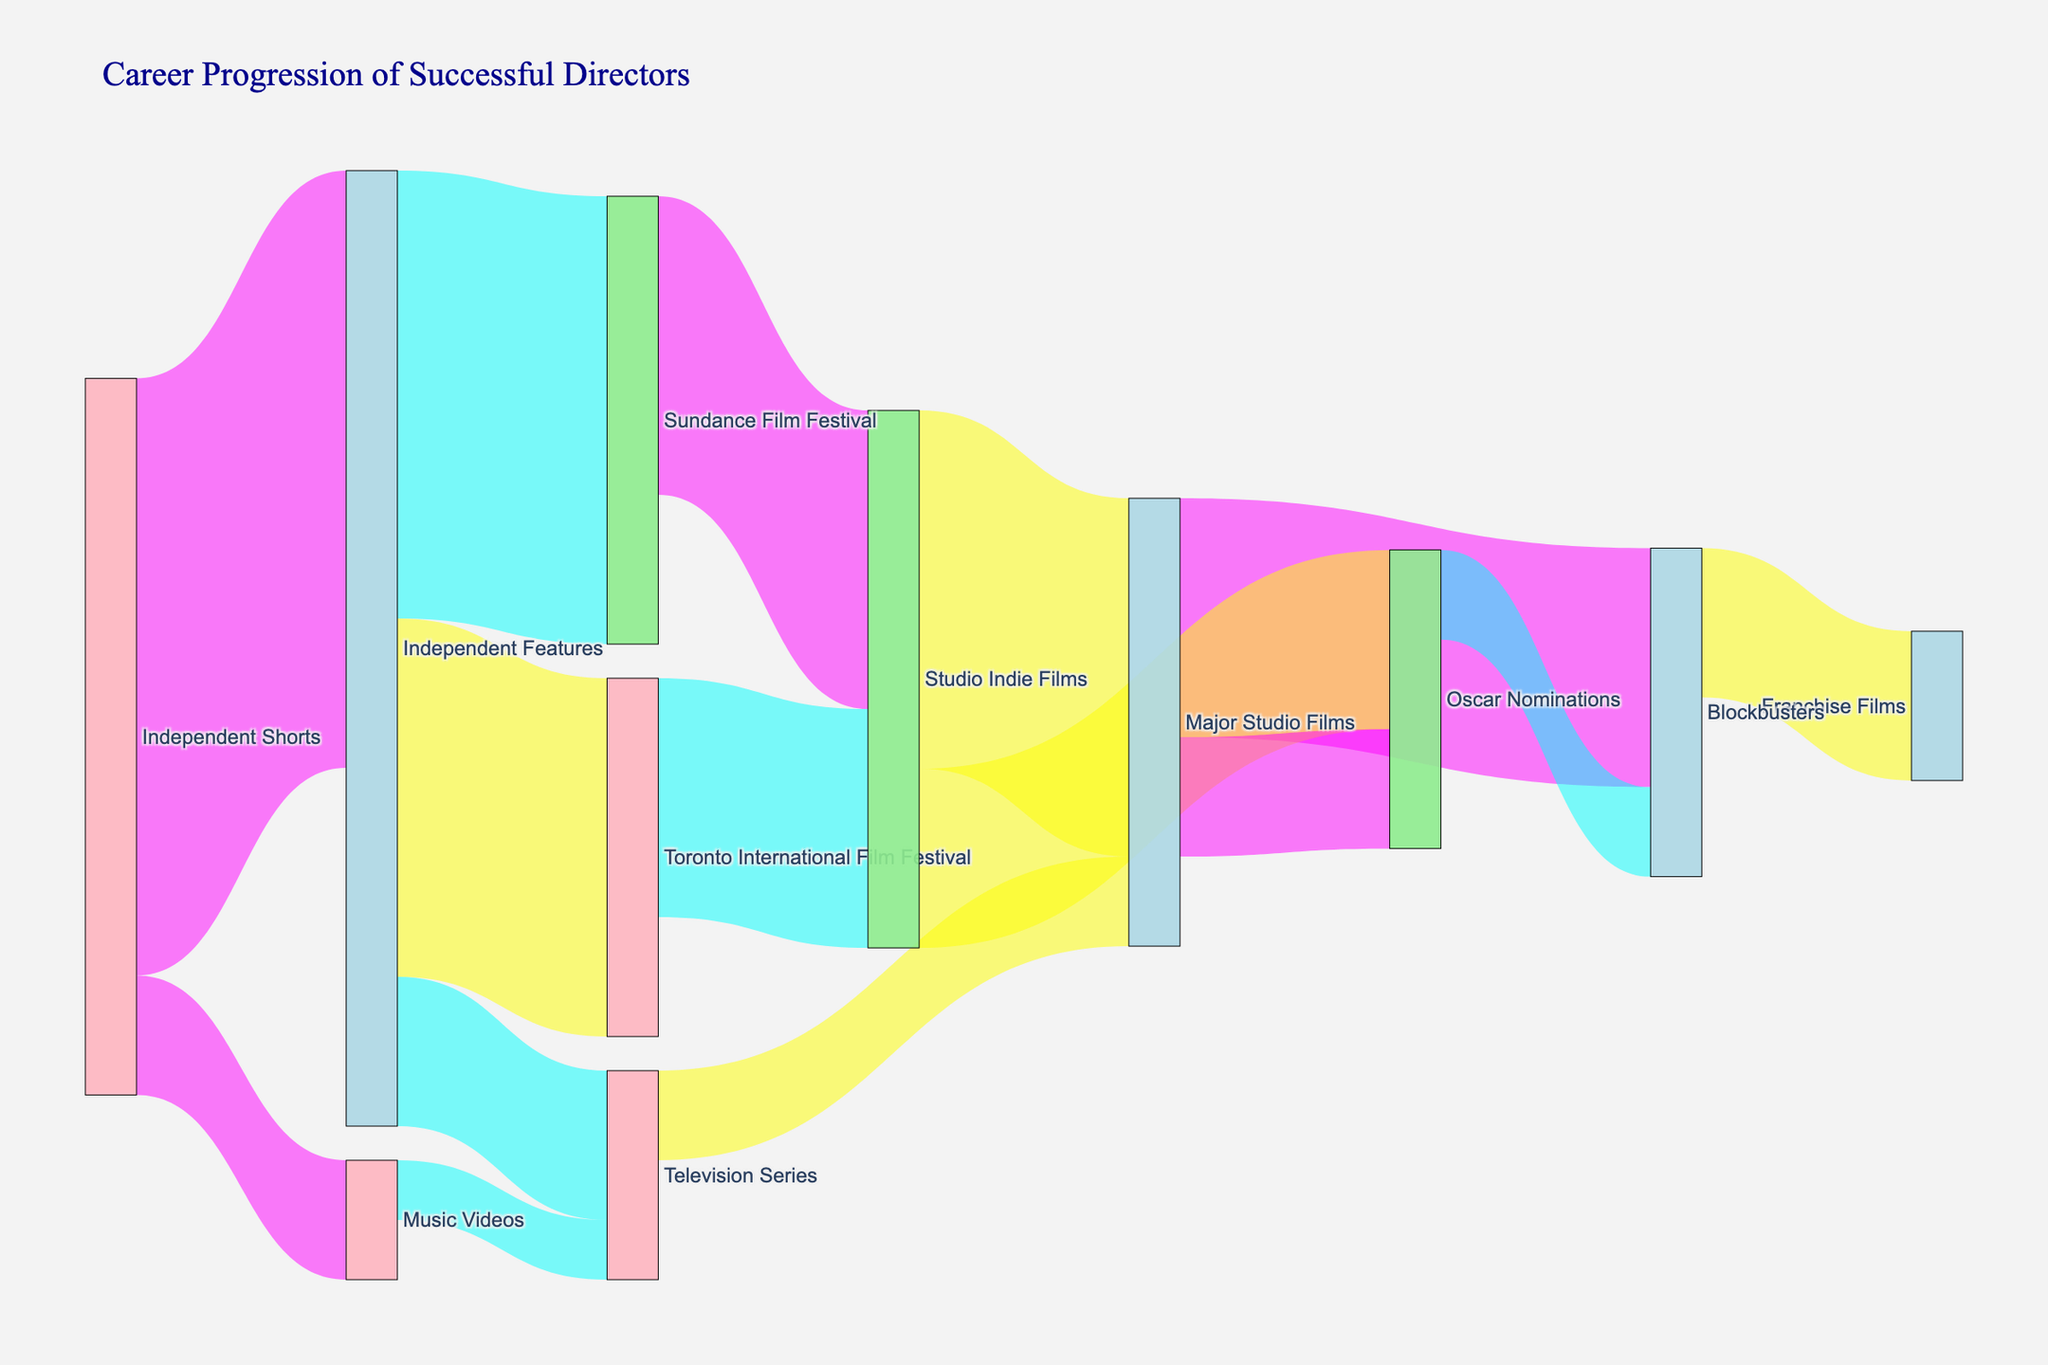What is the title of the Sankey diagram? The title appears at the top of the diagram and is meant to provide an overview or main idea.
Answer: Career Progression of Successful Directors How many directors progressed from 'Independent Shorts' to 'Independent Features'? This can be determined by following the path from 'Independent Shorts' to 'Independent Features' on the diagram and reading the corresponding value.
Answer: 20 What is the combined number of directors who moved from 'Independent Features' to the 'Sundance Film Festival' and 'Toronto International Film Festival'? Sum the values of the paths from 'Independent Features' to 'Sundance Film Festival' and 'Toronto International Film Festival'. This involves simple addition.
Answer: 27 Which pathway has the highest flow value: 'Studio Indie Films' to 'Oscar Nominations' or 'Major Studio Films' to 'Oscar Nominations'? Compare the values of the two pathways by finding the respective flow values and seeing which is greater.
Answer: Studio Indie Films to Oscar Nominations How many directors transitioned from 'Oscar Nominations' to 'Blockbusters'? This can be determined by following the path from 'Oscar Nominations' to 'Blockbusters' on the diagram and reading the corresponding value.
Answer: 3 What is the total number of directors who moved into 'Major Studio Films' from all preceding categories? Add up the values of all paths leading into 'Major Studio Films': 'Studio Indie Films' to 'Major Studio Films' and 'Television Series' to 'Major Studio Films'.
Answer: 15 Which category, 'Independent Features' or 'Major Studio Films', has a higher total value of outgoing flows? Sum the outgoing flows from each category and compare the totals. 'Independent Features' has outgoing flows to 'Sundance Film Festival', 'Toronto International Film Festival', and 'Television Series'. 'Major Studio Films' has outgoing flows to 'Oscar Nominations' and 'Blockbusters'.
Answer: Independent Features How many categories lead to 'Blockbusters'? Count the unique categories that have paths leading to 'Blockbusters'. This can be seen by identifying the incoming flows to 'Blockbusters'.
Answer: 2 Do more directors move from 'Major Studio Films' to 'Oscar Nominations' or from 'Blockbusters' to 'Franchise Films'? Compare the flow values of the paths 'Major Studio Films' to 'Oscar Nominations' and 'Blockbusters' to 'Franchise Films'.
Answer: Blockbusters to Franchise Films What is the flow value from 'Music Videos' to 'Television Series'? Follow the path from 'Music Videos' to 'Television Series' and read the corresponding value.
Answer: 2 